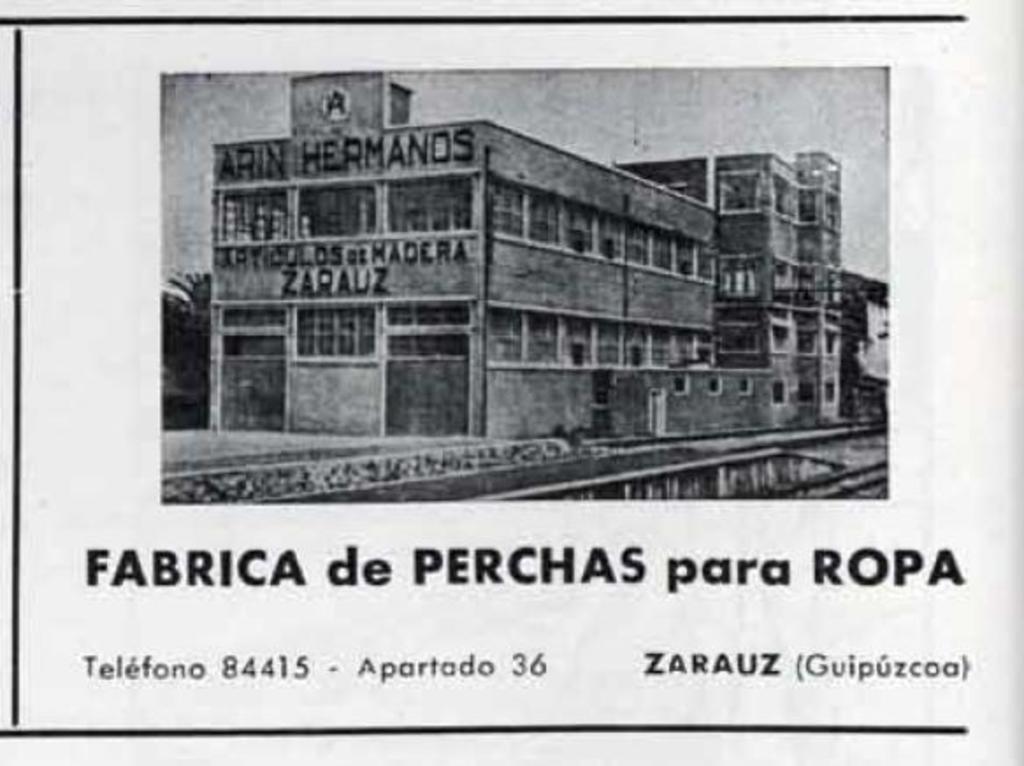In one or two sentences, can you explain what this image depicts? In this picture I can see there is a building and it is having a name plate and this is a black and white picture and there is something written at the bottom of the picture. 